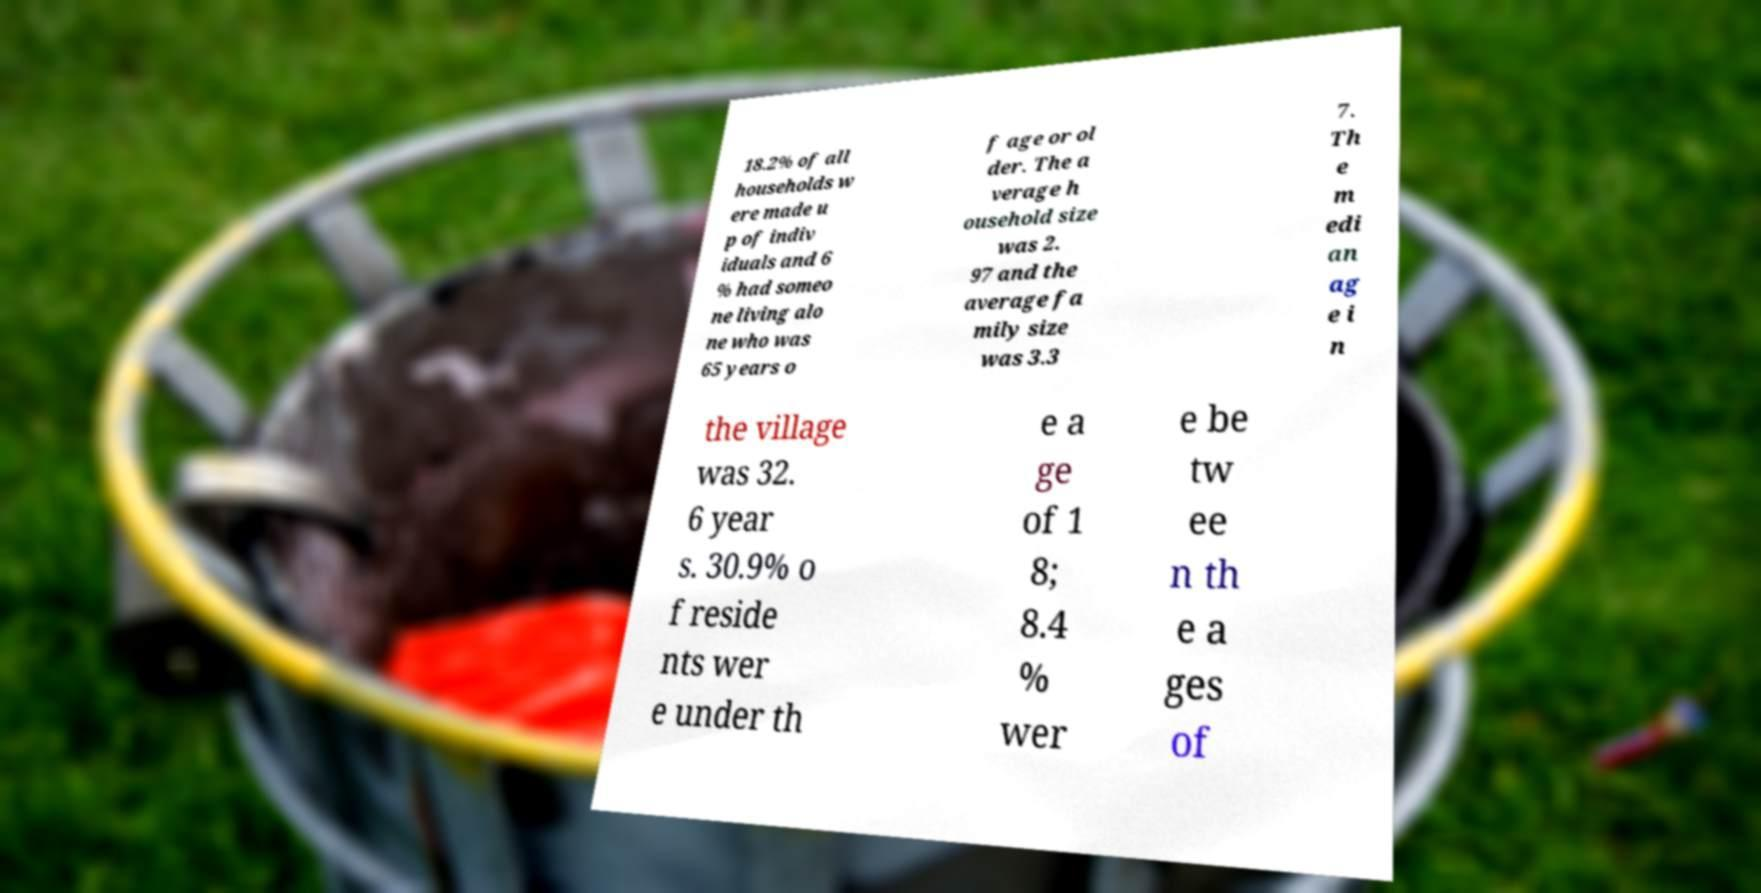Can you read and provide the text displayed in the image?This photo seems to have some interesting text. Can you extract and type it out for me? 18.2% of all households w ere made u p of indiv iduals and 6 % had someo ne living alo ne who was 65 years o f age or ol der. The a verage h ousehold size was 2. 97 and the average fa mily size was 3.3 7. Th e m edi an ag e i n the village was 32. 6 year s. 30.9% o f reside nts wer e under th e a ge of 1 8; 8.4 % wer e be tw ee n th e a ges of 